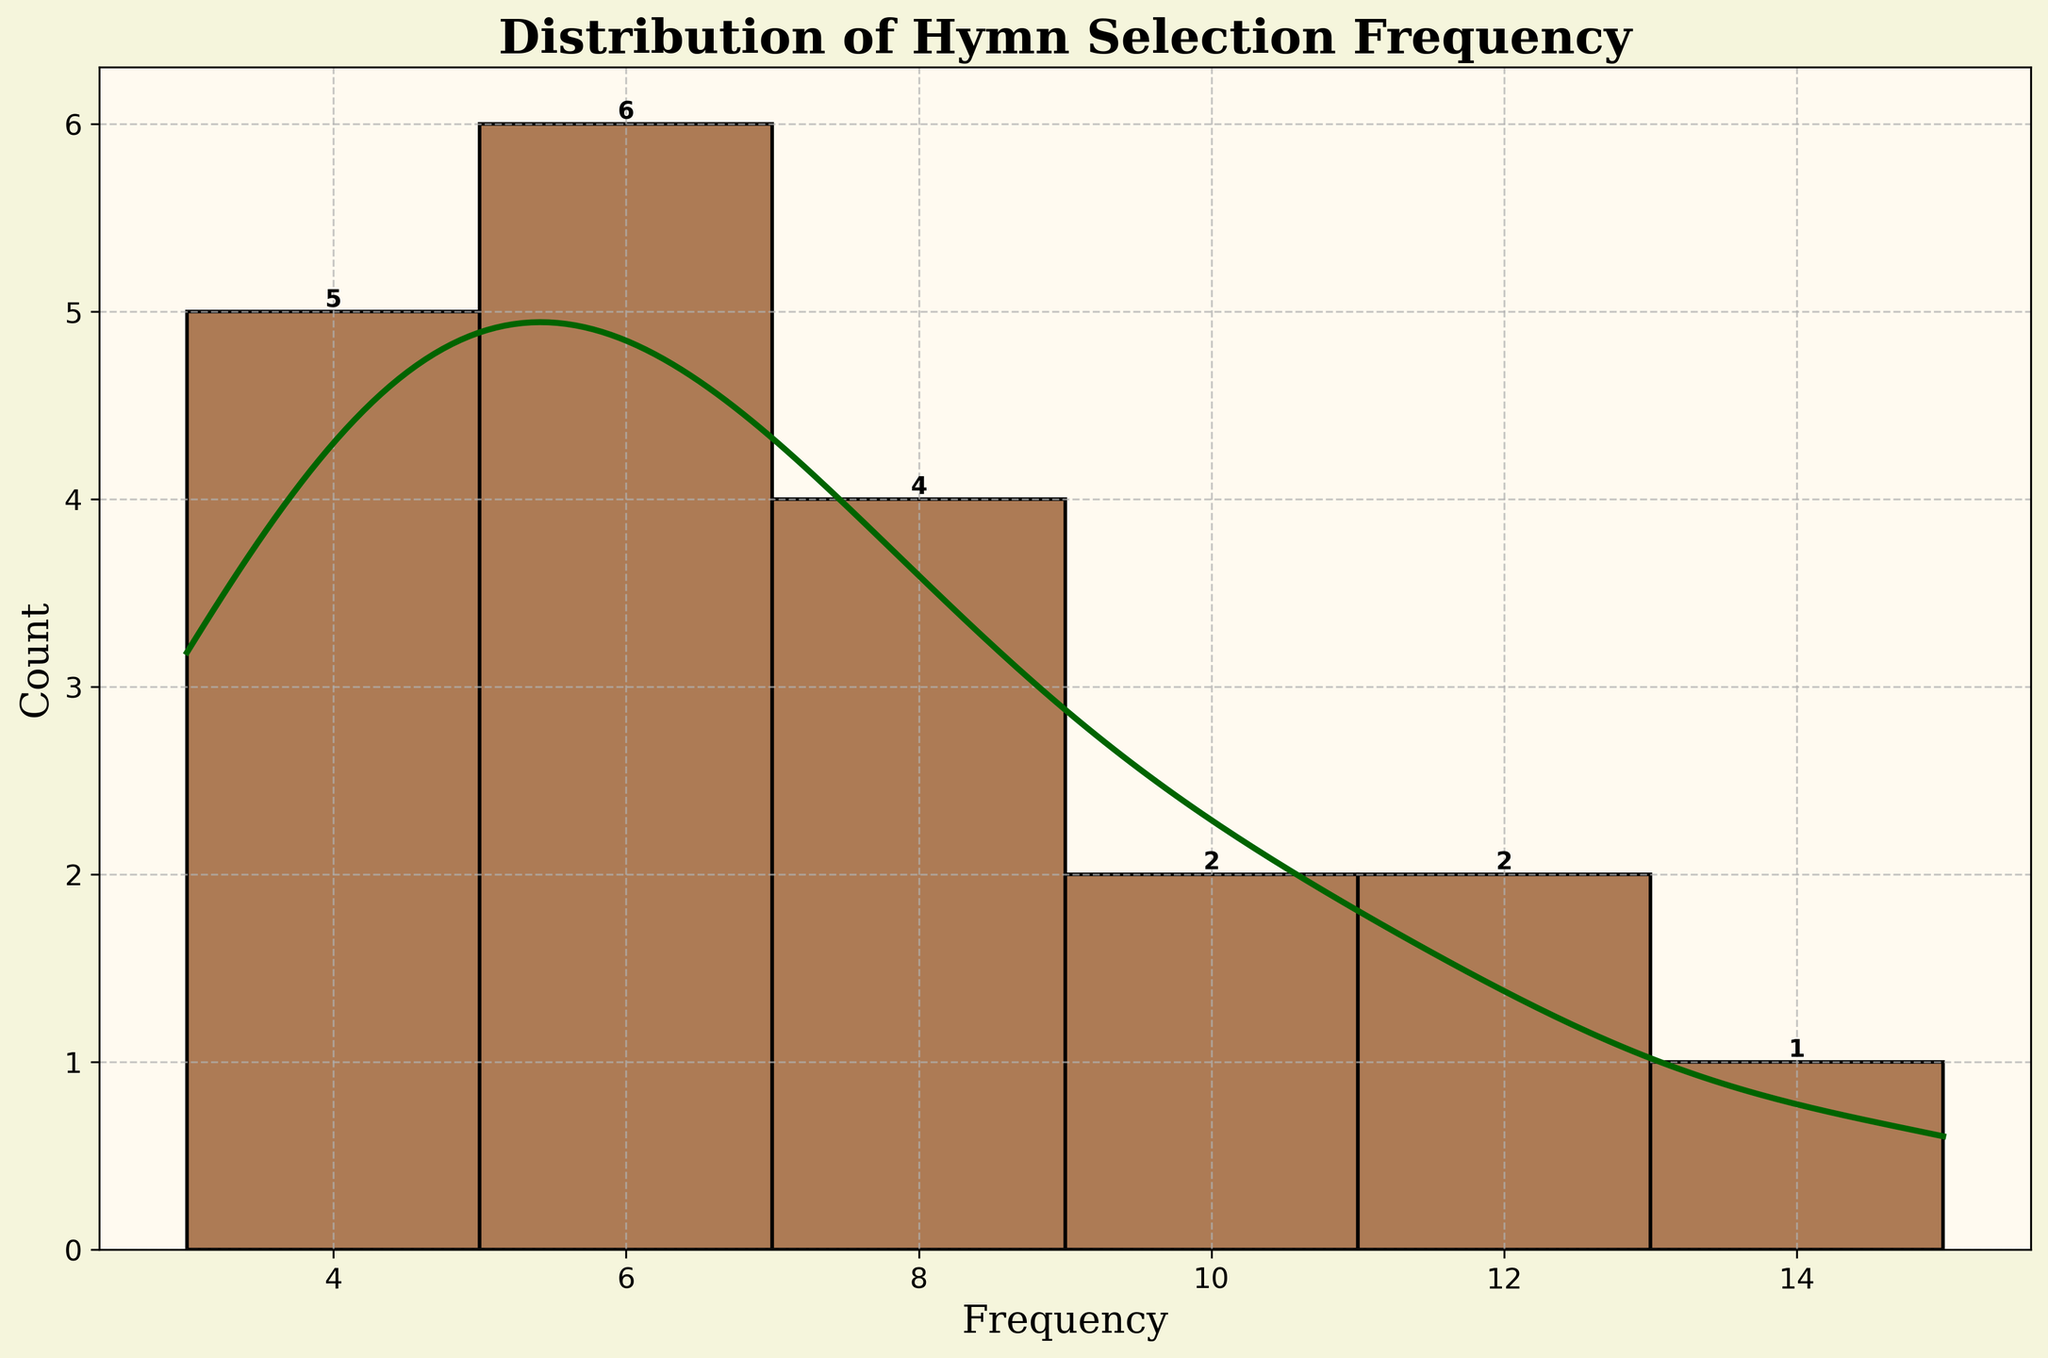What is the title of the plot? The title of the plot is prominently displayed at the top of the figure. Reading it can help viewers quickly understand what the plot is about. The title reads "Distribution of Hymn Selection Frequency".
Answer: Distribution of Hymn Selection Frequency What is the range of hymn selection frequency shown on the x-axis? The x-axis represents the Frequency of hymn selections. By examining the figures, one can see the range starts from 3 and goes up to 15.
Answer: 3 to 15 Which frequency has the highest count of hymns? To determine this, look at the bar (bin) that reaches the highest count on the y-axis. The bin reaching up to the highest count corresponds to a frequency of 6 hymns.
Answer: 6 How many hymns were selected 10 times? By examining the height of the bar corresponding to a frequency of 10 on the x-axis, you can count the total number. The bar's height reaches 1, indicating there is one hymn selected 10 times.
Answer: 1 What color is the KDE line, and what does it represent? The KDE (Kernel Density Estimate) line's color can be observed directly in the plot, which is dark green. This line represents the smoothed estimate of the distribution of hymn selection frequencies.
Answer: Dark green Are more hymns selected during Ordinary Time compared to Advent? To answer this, you would count the frequencies of hymns listed under Ordinary Time and Advent. Ordinary Time selections are "Holy Holy Holy" (8), "Come Thou Fount of Every Blessing" (7), "Amazing Grace" (9), "Be Thou My Vision" (6), "Joyful Joyful We Adore Thee" (6), "Christ Is Made the Sure Foundation" (5), "How Great Thou Art" (8), "All Creatures of Our God and King" (6), and "Guide Me O Thou Great Jehovah" (5), which sums to 60. Advent selections are "O Come All Ye Faithful" (12) and "O Come O Come Emmanuel" (11), totaling 23.
Answer: Yes What is the average hymn selection frequency? To find the average, add all the hymn frequencies and divide by the number of hymns. The sum of the frequencies is 137, and there are 18 hymns. So, the average is 137 divided by 18.
Answer: 7.61 Which season has the broadest range of hymn selection frequencies? By breaking down hymn selections by season and finding the range, Ordinary Time has the broadest range with frequencies from 5 to 9.
Answer: Ordinary Time Which seasons have the most hymn selections repeated more than 5 times? By examining the list of hymns, the only seasons with hymn selections repeated more than 5 times are Ordinary Time and Advent. Ordinary Time hymns repeated more than 5 times are 6: "Holy Holy Holy" (8), "Come Thou Fount of Every Blessing" (7), "Amazing Grace" (9), "Be Thou My Vision" (6), "Joyful Joyful We Adore Thee" (6), and "How Great Thou Art" (8). Advent's hymns repeated more than 5 times are "O Come All Ye Faithful" (12) and "O Come O Come Emmanuel" (11).
Answer: Ordinary Time and Advent 